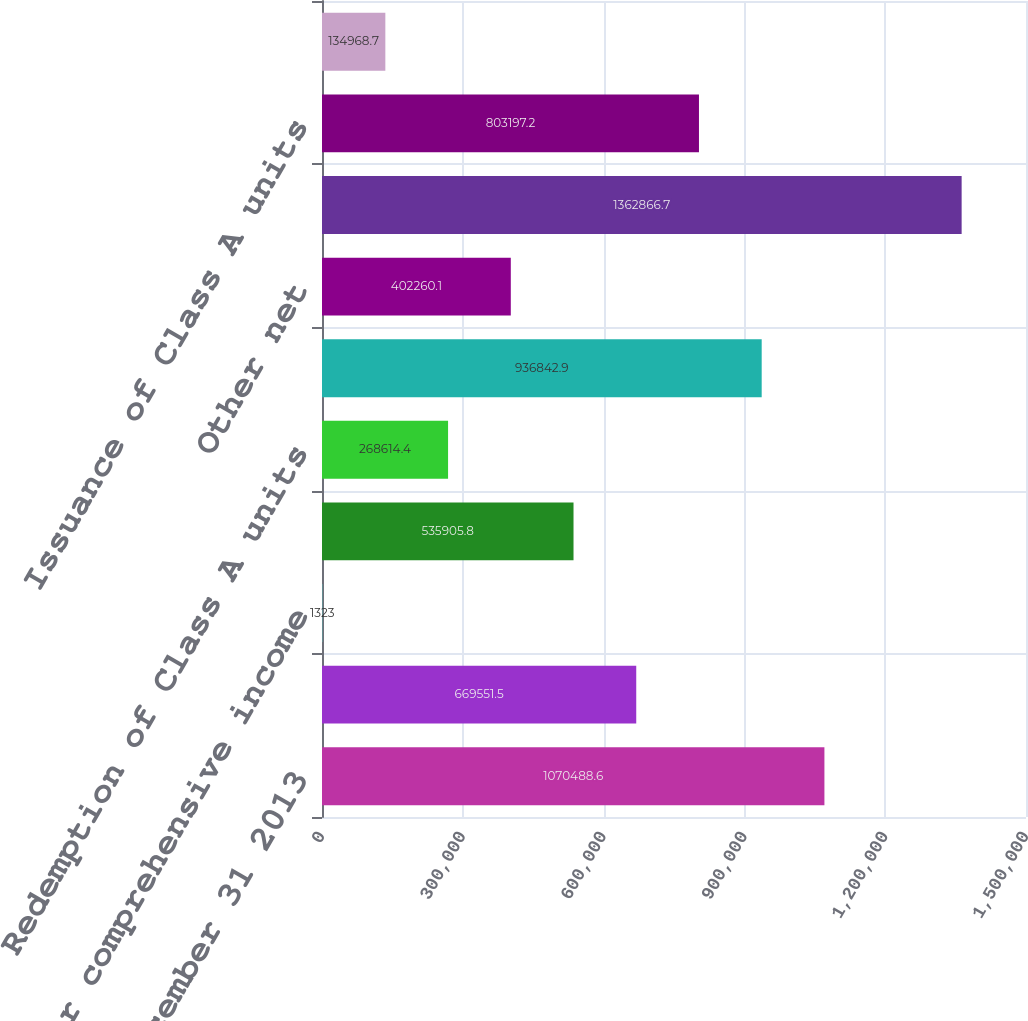<chart> <loc_0><loc_0><loc_500><loc_500><bar_chart><fcel>Balance at December 31 2013<fcel>Net income<fcel>Other comprehensive income<fcel>Distributions<fcel>Redemption of Class A units<fcel>Adjustments to carry<fcel>Other net<fcel>Balance at December 31 2014<fcel>Issuance of Class A units<fcel>Issuance of Series D-17<nl><fcel>1.07049e+06<fcel>669552<fcel>1323<fcel>535906<fcel>268614<fcel>936843<fcel>402260<fcel>1.36287e+06<fcel>803197<fcel>134969<nl></chart> 